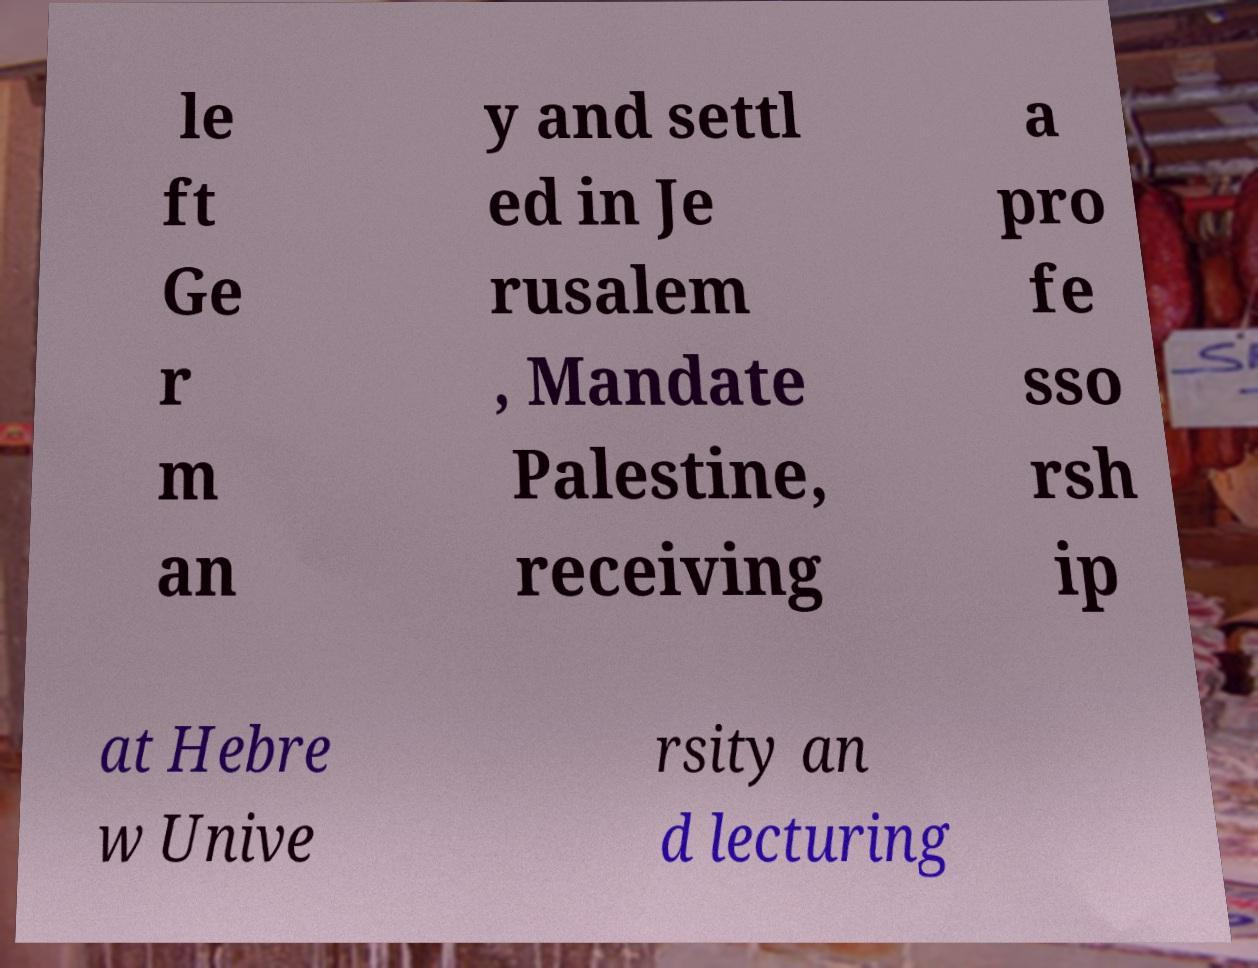Please identify and transcribe the text found in this image. le ft Ge r m an y and settl ed in Je rusalem , Mandate Palestine, receiving a pro fe sso rsh ip at Hebre w Unive rsity an d lecturing 